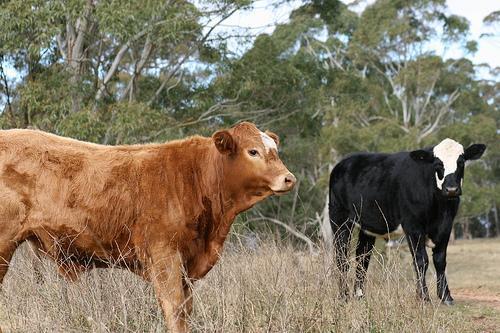How many cows are there?
Give a very brief answer. 2. 